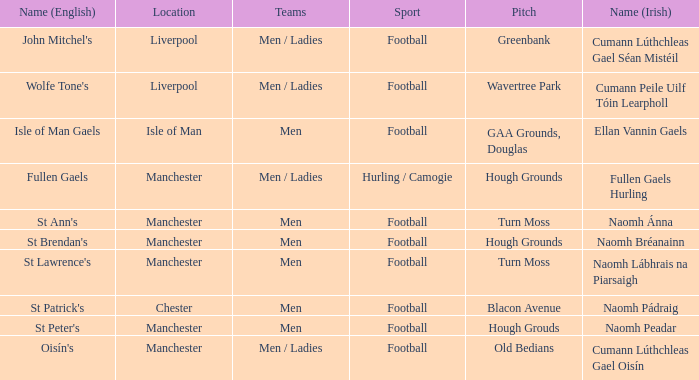What is the English Name of the Location in Chester? St Patrick's. 